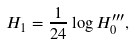<formula> <loc_0><loc_0><loc_500><loc_500>H _ { 1 } = \frac { 1 } { 2 4 } \log H _ { 0 } ^ { \prime \prime \prime } ,</formula> 